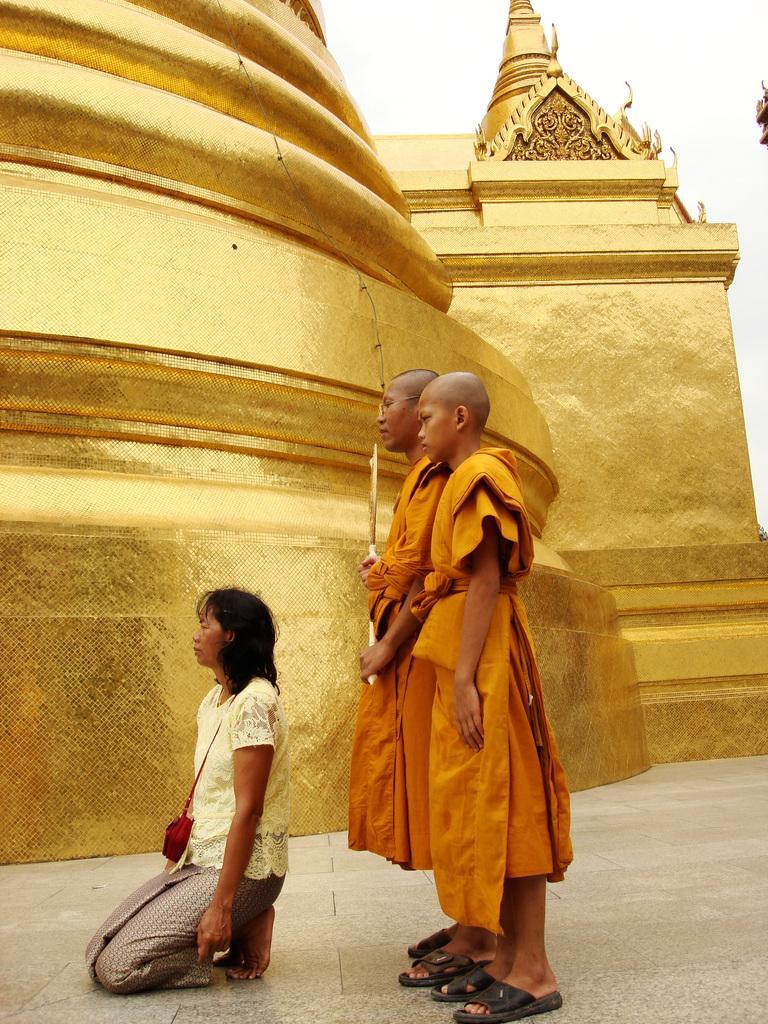How would you summarize this image in a sentence or two? There are two people standing and this woman sitting on knees and wire bag. In the background we can see gold wall and sky. 